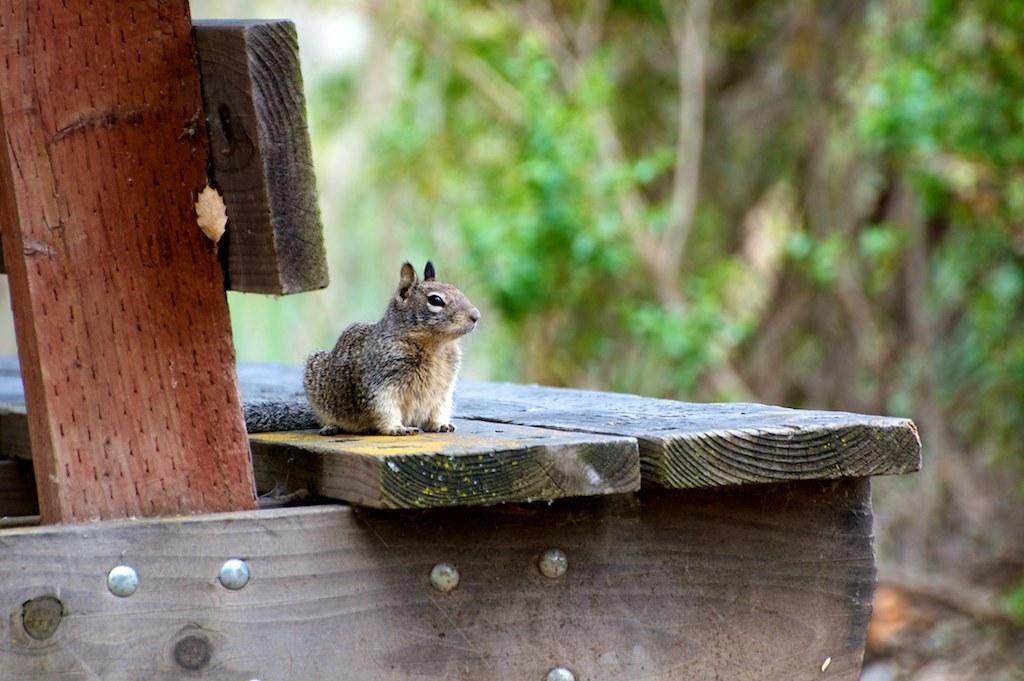What type of animal is in the image? There is a squirrel in the image. Where is the squirrel located? The squirrel is on a wooden plank. What else can be seen in the image besides the squirrel? There are wooden planks in the image. How many giants can be seen walking on the sidewalk in the image? There are no giants or sidewalks present in the image; it features a squirrel on a wooden plank. What type of clouds are visible in the image? There are no clouds visible in the image; it features a squirrel on a wooden plank. 